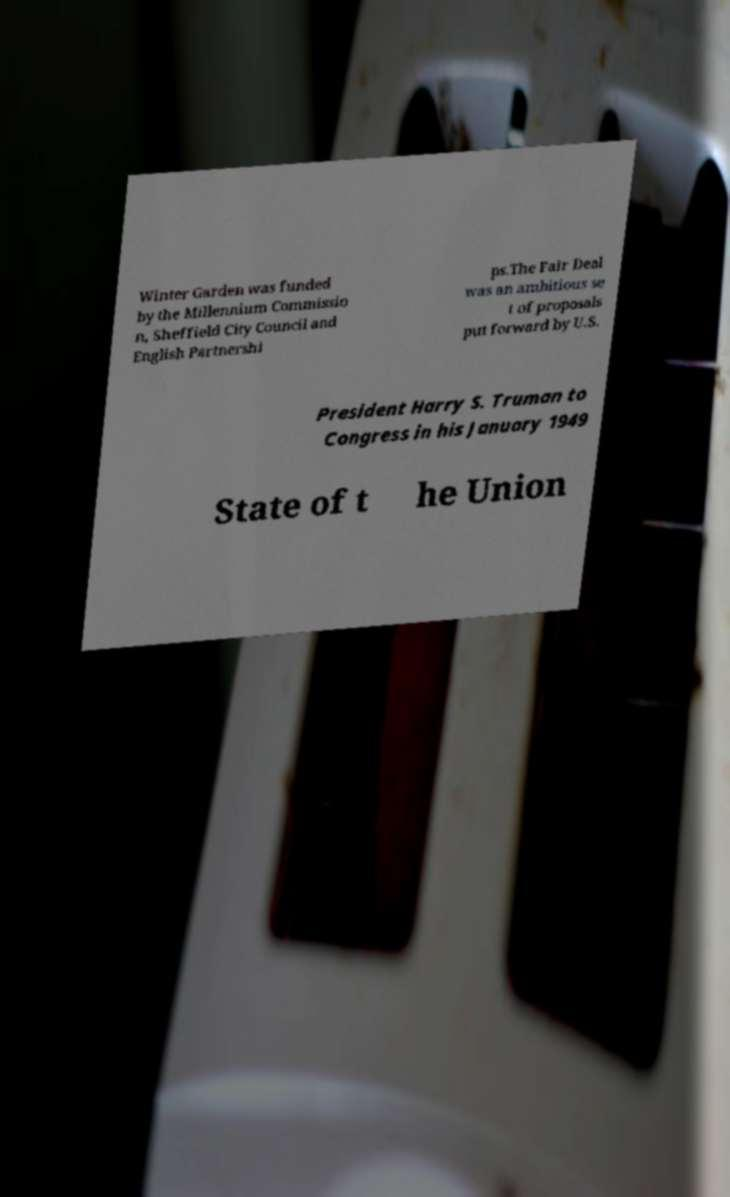What messages or text are displayed in this image? I need them in a readable, typed format. Winter Garden was funded by the Millennium Commissio n, Sheffield City Council and English Partnershi ps.The Fair Deal was an ambitious se t of proposals put forward by U.S. President Harry S. Truman to Congress in his January 1949 State of t he Union 